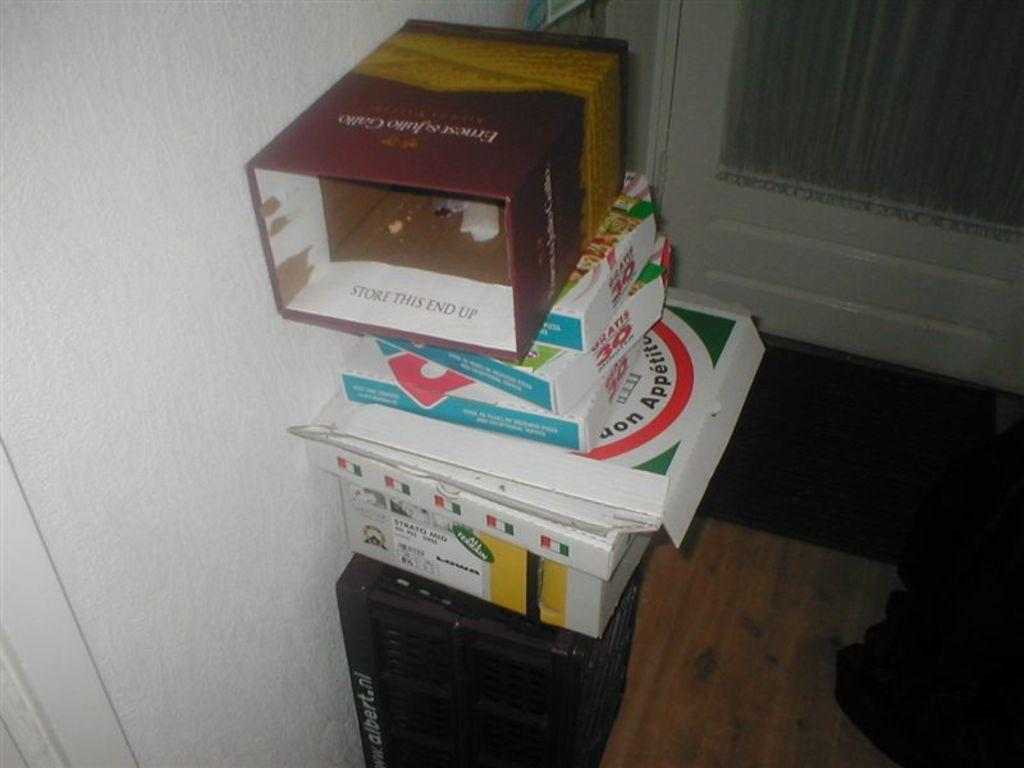<image>
Write a terse but informative summary of the picture. Boxes of garbage with one saying "Store This End Up". 